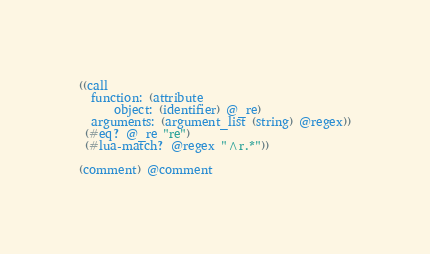Convert code to text. <code><loc_0><loc_0><loc_500><loc_500><_Scheme_>((call
  function: (attribute
	  object: (identifier) @_re)
  arguments: (argument_list (string) @regex))
 (#eq? @_re "re")
 (#lua-match? @regex "^r.*"))

(comment) @comment
</code> 